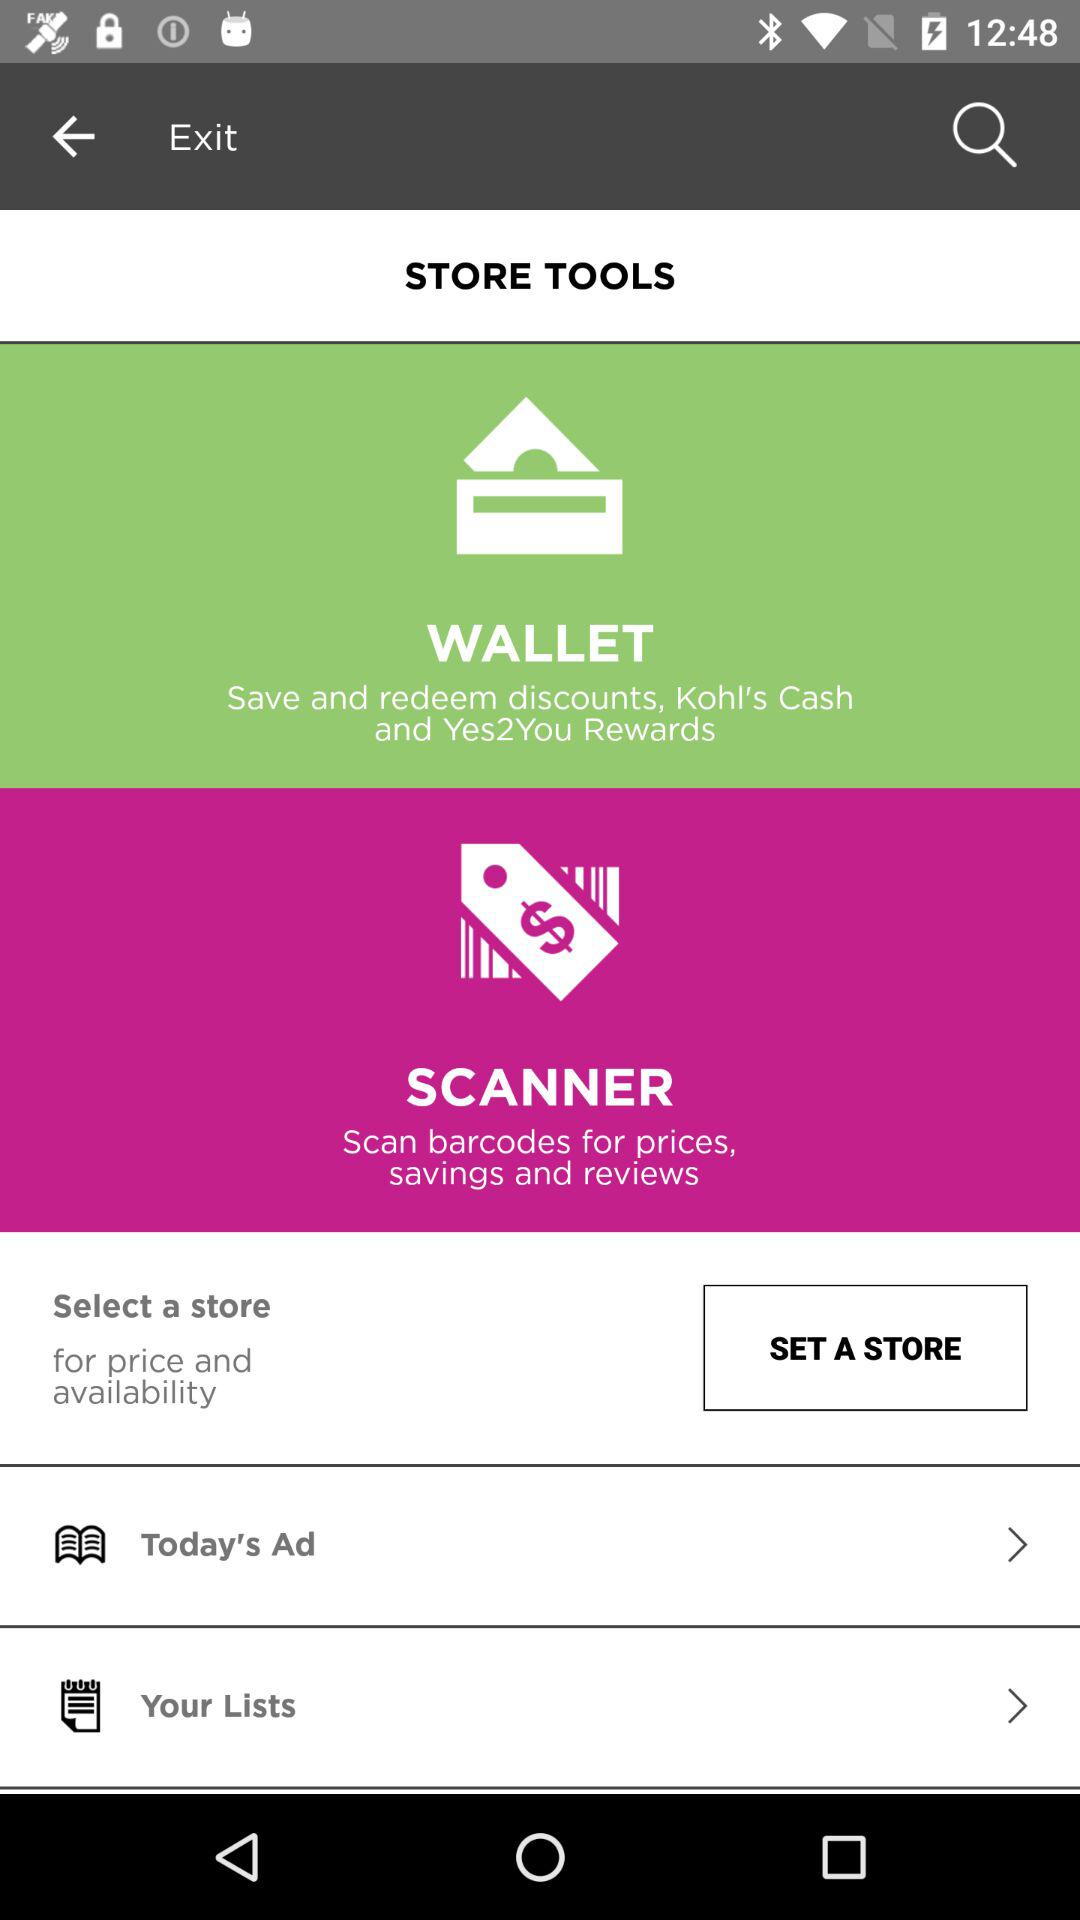Which tool is used to save discounts, redeem discounts, earn Kohl's Cash and earn Yes2You Rewards? The tool that is used to save discounts, redeem discounts, earn Kohl's Cash and earn Yes2You Rewards is "WALLET". 